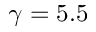Convert formula to latex. <formula><loc_0><loc_0><loc_500><loc_500>\gamma = 5 . 5</formula> 